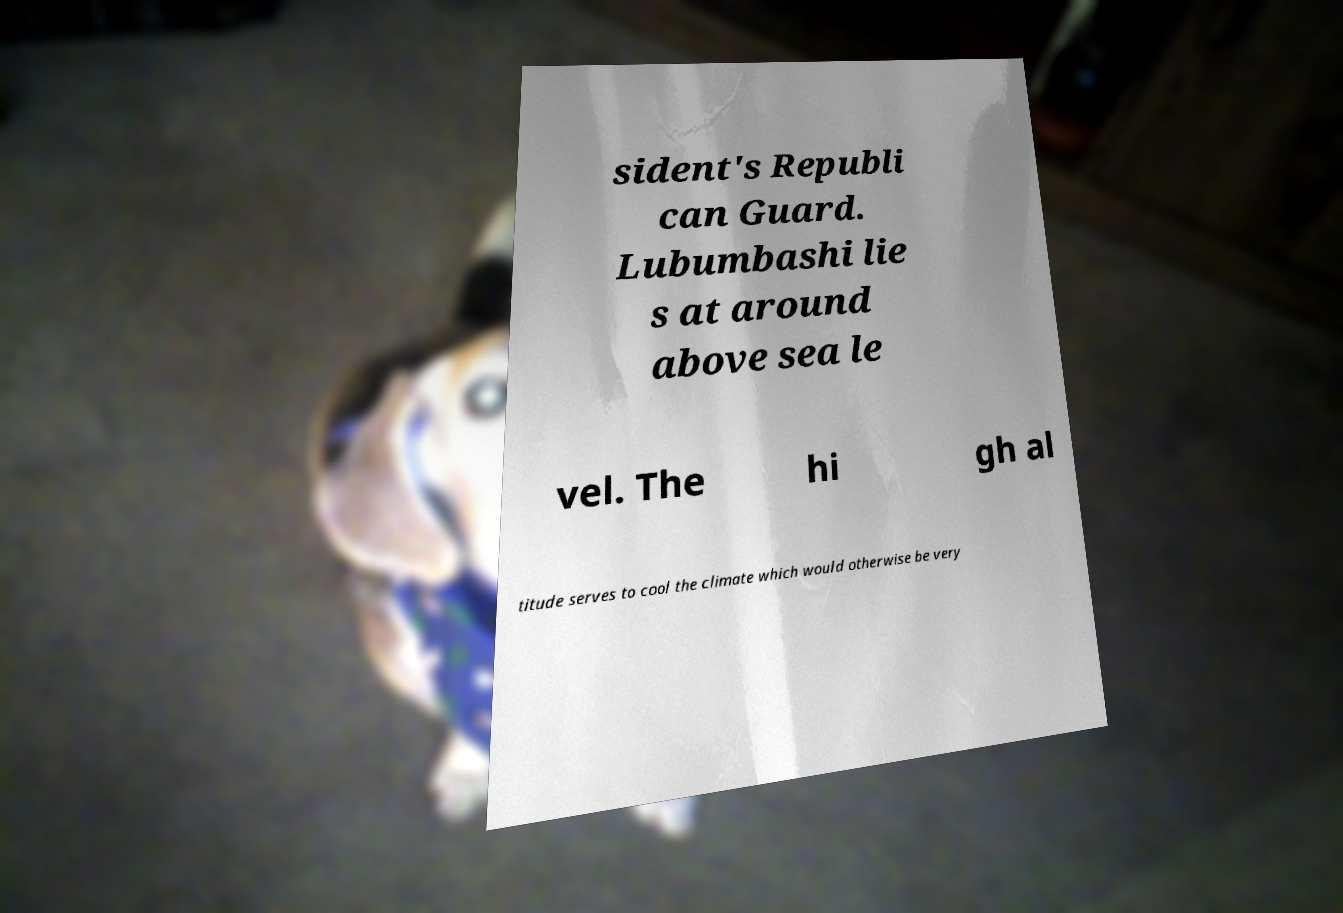Can you read and provide the text displayed in the image?This photo seems to have some interesting text. Can you extract and type it out for me? sident's Republi can Guard. Lubumbashi lie s at around above sea le vel. The hi gh al titude serves to cool the climate which would otherwise be very 